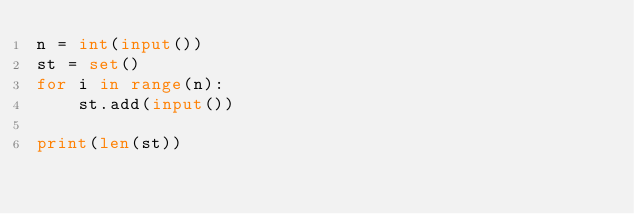Convert code to text. <code><loc_0><loc_0><loc_500><loc_500><_Python_>n = int(input())
st = set()
for i in range(n):
    st.add(input())

print(len(st))
</code> 